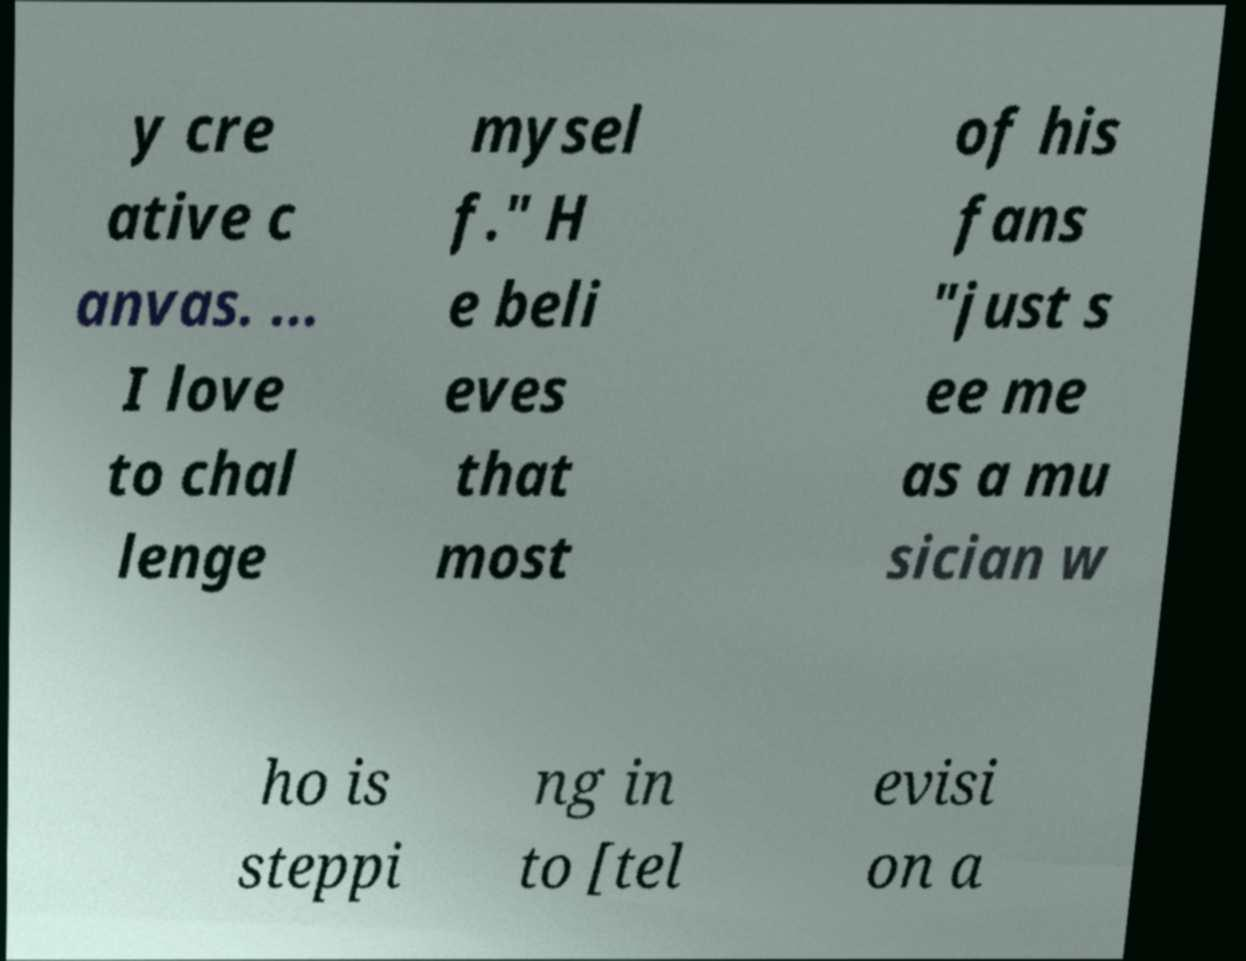Can you read and provide the text displayed in the image?This photo seems to have some interesting text. Can you extract and type it out for me? y cre ative c anvas. ... I love to chal lenge mysel f." H e beli eves that most of his fans "just s ee me as a mu sician w ho is steppi ng in to [tel evisi on a 